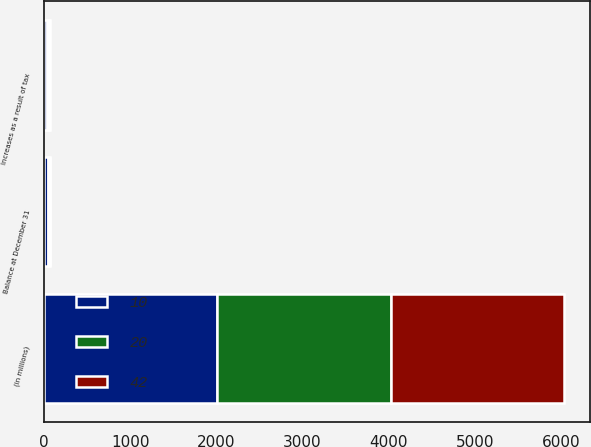Convert chart. <chart><loc_0><loc_0><loc_500><loc_500><stacked_bar_chart><ecel><fcel>(in millions)<fcel>Increases as a result of tax<fcel>Balance at December 31<nl><fcel>10<fcel>2012<fcel>33<fcel>42<nl><fcel>20<fcel>2011<fcel>22<fcel>20<nl><fcel>42<fcel>2010<fcel>10<fcel>10<nl></chart> 